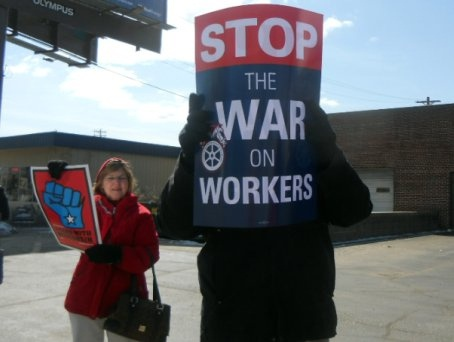Describe the objects in this image and their specific colors. I can see people in black, purple, and darkblue tones, people in black, maroon, gray, and brown tones, and handbag in black, gray, and purple tones in this image. 